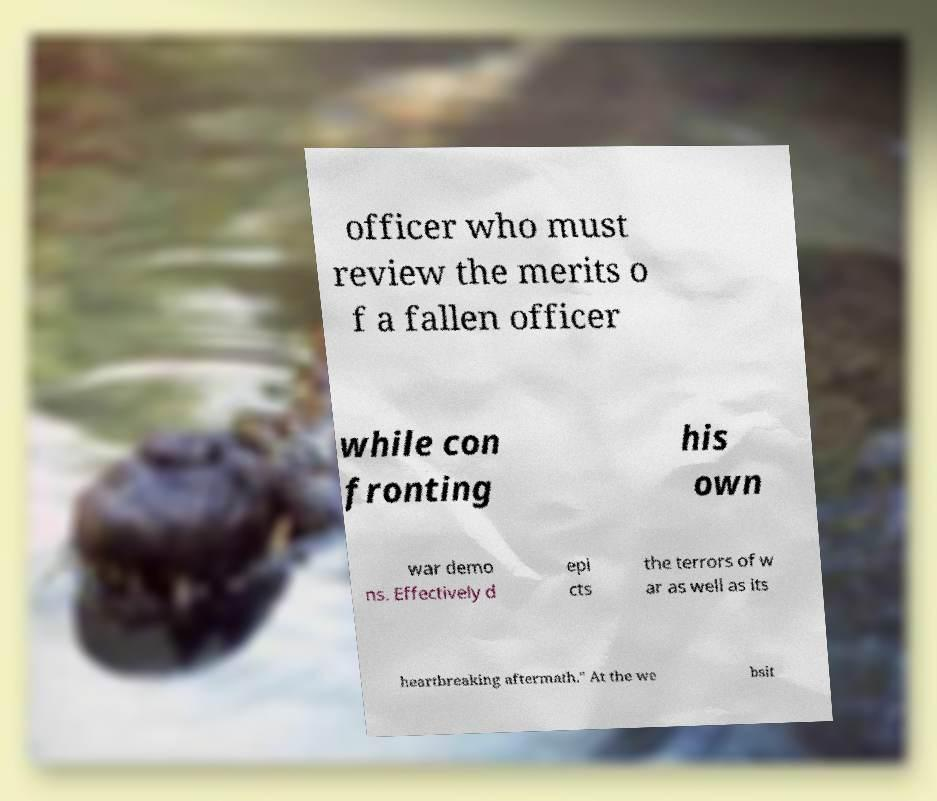Please read and relay the text visible in this image. What does it say? officer who must review the merits o f a fallen officer while con fronting his own war demo ns. Effectively d epi cts the terrors of w ar as well as its heartbreaking aftermath." At the we bsit 